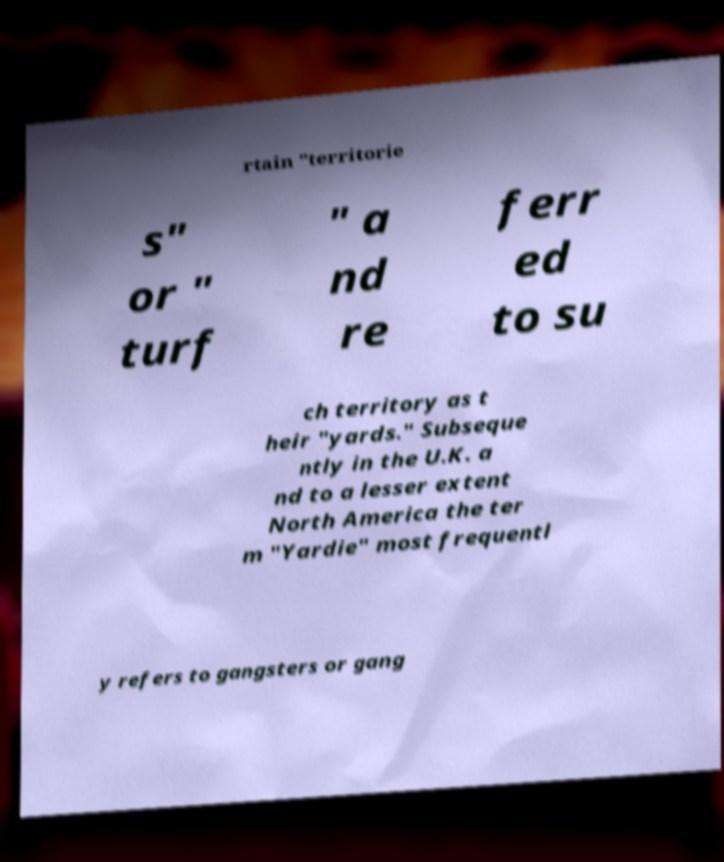Please read and relay the text visible in this image. What does it say? rtain "territorie s" or " turf " a nd re ferr ed to su ch territory as t heir "yards." Subseque ntly in the U.K. a nd to a lesser extent North America the ter m "Yardie" most frequentl y refers to gangsters or gang 